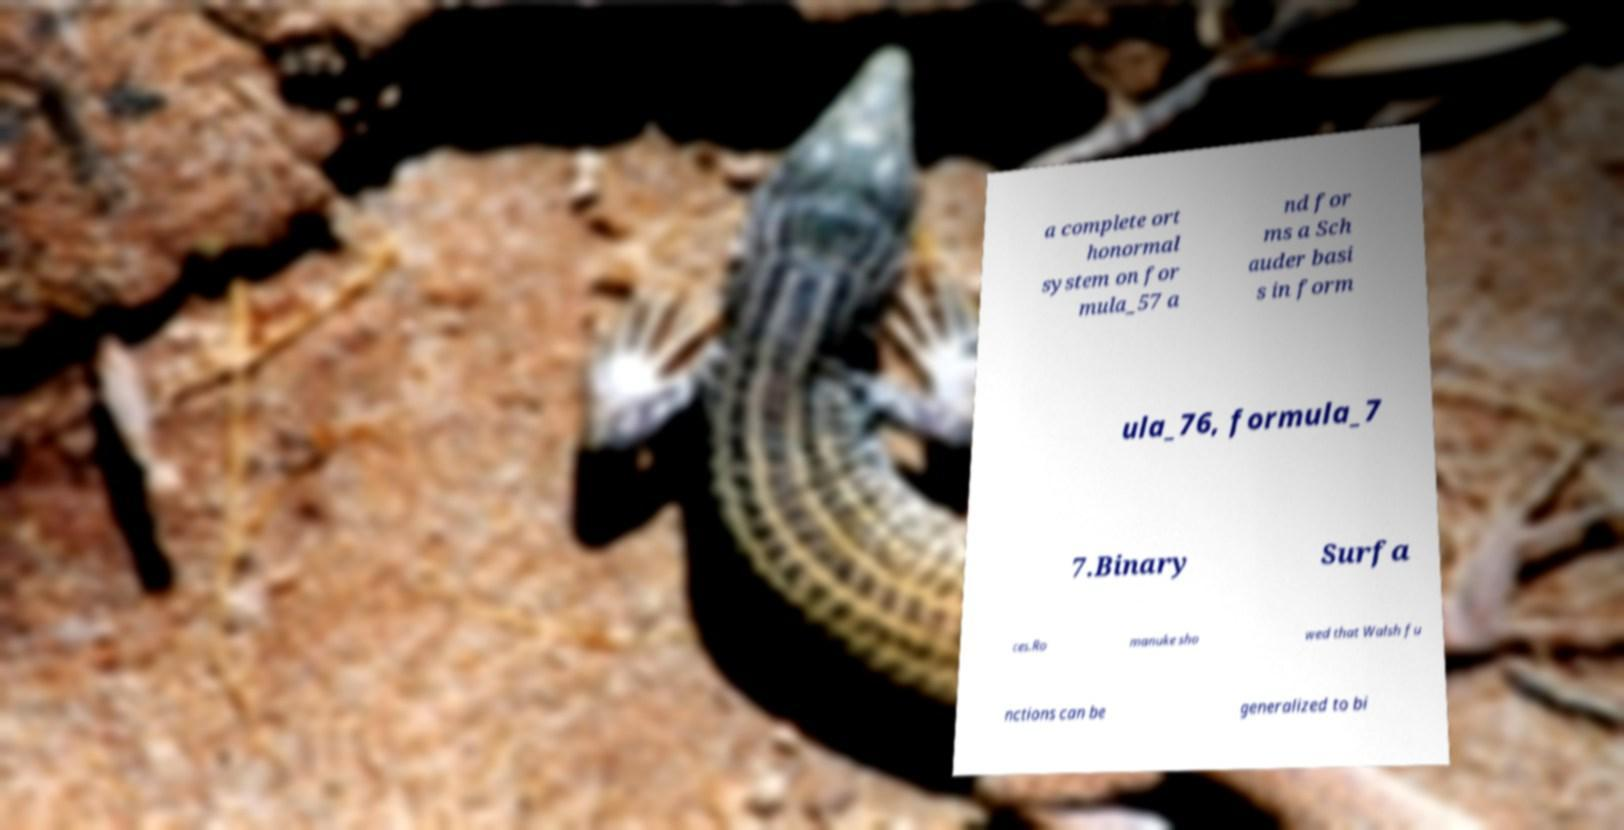Could you assist in decoding the text presented in this image and type it out clearly? a complete ort honormal system on for mula_57 a nd for ms a Sch auder basi s in form ula_76, formula_7 7.Binary Surfa ces.Ro manuke sho wed that Walsh fu nctions can be generalized to bi 